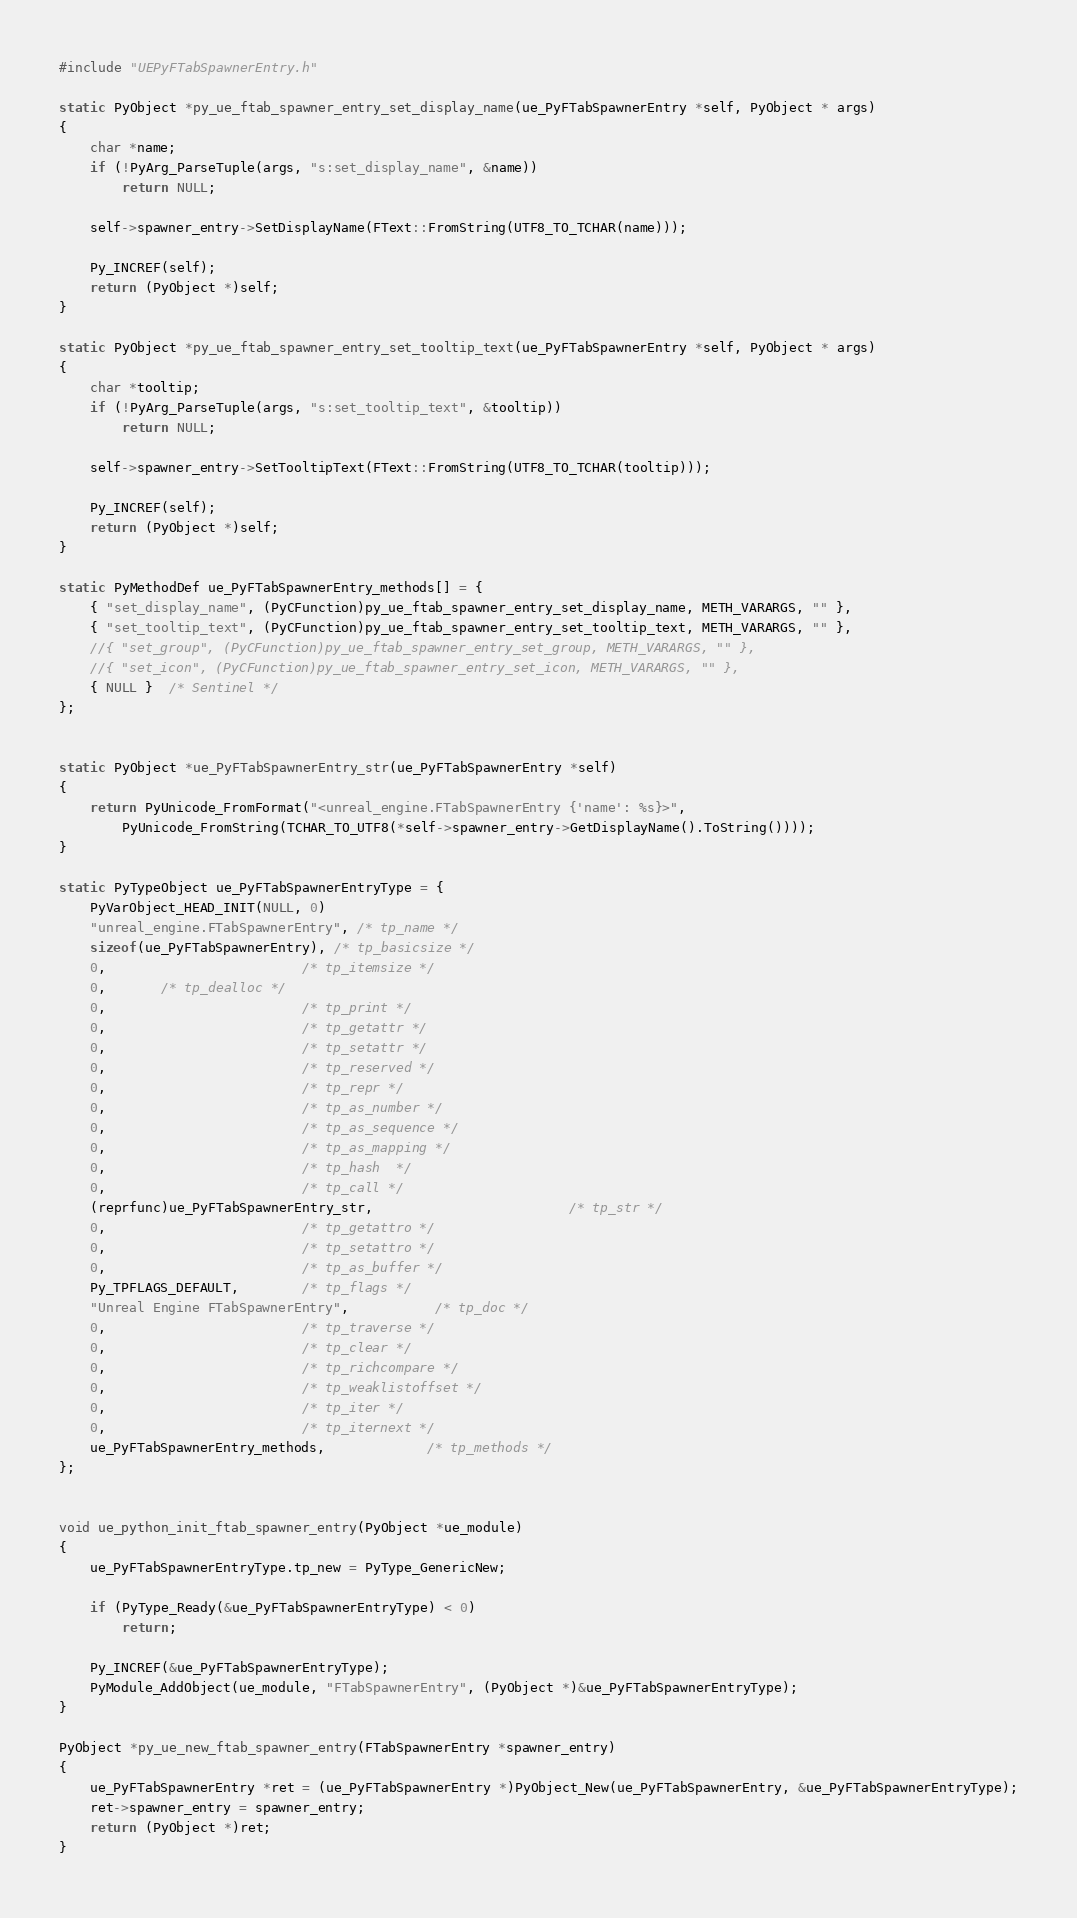<code> <loc_0><loc_0><loc_500><loc_500><_C++_>
#include "UEPyFTabSpawnerEntry.h"

static PyObject *py_ue_ftab_spawner_entry_set_display_name(ue_PyFTabSpawnerEntry *self, PyObject * args)
{
	char *name;
	if (!PyArg_ParseTuple(args, "s:set_display_name", &name))
		return NULL;

	self->spawner_entry->SetDisplayName(FText::FromString(UTF8_TO_TCHAR(name)));

	Py_INCREF(self);
	return (PyObject *)self;
}

static PyObject *py_ue_ftab_spawner_entry_set_tooltip_text(ue_PyFTabSpawnerEntry *self, PyObject * args)
{
	char *tooltip;
	if (!PyArg_ParseTuple(args, "s:set_tooltip_text", &tooltip))
		return NULL;

	self->spawner_entry->SetTooltipText(FText::FromString(UTF8_TO_TCHAR(tooltip)));

	Py_INCREF(self);
	return (PyObject *)self;
}

static PyMethodDef ue_PyFTabSpawnerEntry_methods[] = {
	{ "set_display_name", (PyCFunction)py_ue_ftab_spawner_entry_set_display_name, METH_VARARGS, "" },
	{ "set_tooltip_text", (PyCFunction)py_ue_ftab_spawner_entry_set_tooltip_text, METH_VARARGS, "" },
	//{ "set_group", (PyCFunction)py_ue_ftab_spawner_entry_set_group, METH_VARARGS, "" },
	//{ "set_icon", (PyCFunction)py_ue_ftab_spawner_entry_set_icon, METH_VARARGS, "" },
	{ NULL }  /* Sentinel */
};


static PyObject *ue_PyFTabSpawnerEntry_str(ue_PyFTabSpawnerEntry *self)
{
	return PyUnicode_FromFormat("<unreal_engine.FTabSpawnerEntry {'name': %s}>",
		PyUnicode_FromString(TCHAR_TO_UTF8(*self->spawner_entry->GetDisplayName().ToString())));
}

static PyTypeObject ue_PyFTabSpawnerEntryType = {
	PyVarObject_HEAD_INIT(NULL, 0)
	"unreal_engine.FTabSpawnerEntry", /* tp_name */
	sizeof(ue_PyFTabSpawnerEntry), /* tp_basicsize */
	0,                         /* tp_itemsize */
	0,       /* tp_dealloc */
	0,                         /* tp_print */
	0,                         /* tp_getattr */
	0,                         /* tp_setattr */
	0,                         /* tp_reserved */
	0,                         /* tp_repr */
	0,                         /* tp_as_number */
	0,                         /* tp_as_sequence */
	0,                         /* tp_as_mapping */
	0,                         /* tp_hash  */
	0,                         /* tp_call */
	(reprfunc)ue_PyFTabSpawnerEntry_str,                         /* tp_str */
	0,                         /* tp_getattro */
	0,                         /* tp_setattro */
	0,                         /* tp_as_buffer */
	Py_TPFLAGS_DEFAULT,        /* tp_flags */
	"Unreal Engine FTabSpawnerEntry",           /* tp_doc */
	0,                         /* tp_traverse */
	0,                         /* tp_clear */
	0,                         /* tp_richcompare */
	0,                         /* tp_weaklistoffset */
	0,                         /* tp_iter */
	0,                         /* tp_iternext */
	ue_PyFTabSpawnerEntry_methods,             /* tp_methods */
};


void ue_python_init_ftab_spawner_entry(PyObject *ue_module)
{
	ue_PyFTabSpawnerEntryType.tp_new = PyType_GenericNew;

	if (PyType_Ready(&ue_PyFTabSpawnerEntryType) < 0)
		return;

	Py_INCREF(&ue_PyFTabSpawnerEntryType);
	PyModule_AddObject(ue_module, "FTabSpawnerEntry", (PyObject *)&ue_PyFTabSpawnerEntryType);
}

PyObject *py_ue_new_ftab_spawner_entry(FTabSpawnerEntry *spawner_entry)
{
	ue_PyFTabSpawnerEntry *ret = (ue_PyFTabSpawnerEntry *)PyObject_New(ue_PyFTabSpawnerEntry, &ue_PyFTabSpawnerEntryType);
	ret->spawner_entry = spawner_entry;
	return (PyObject *)ret;
}
</code> 